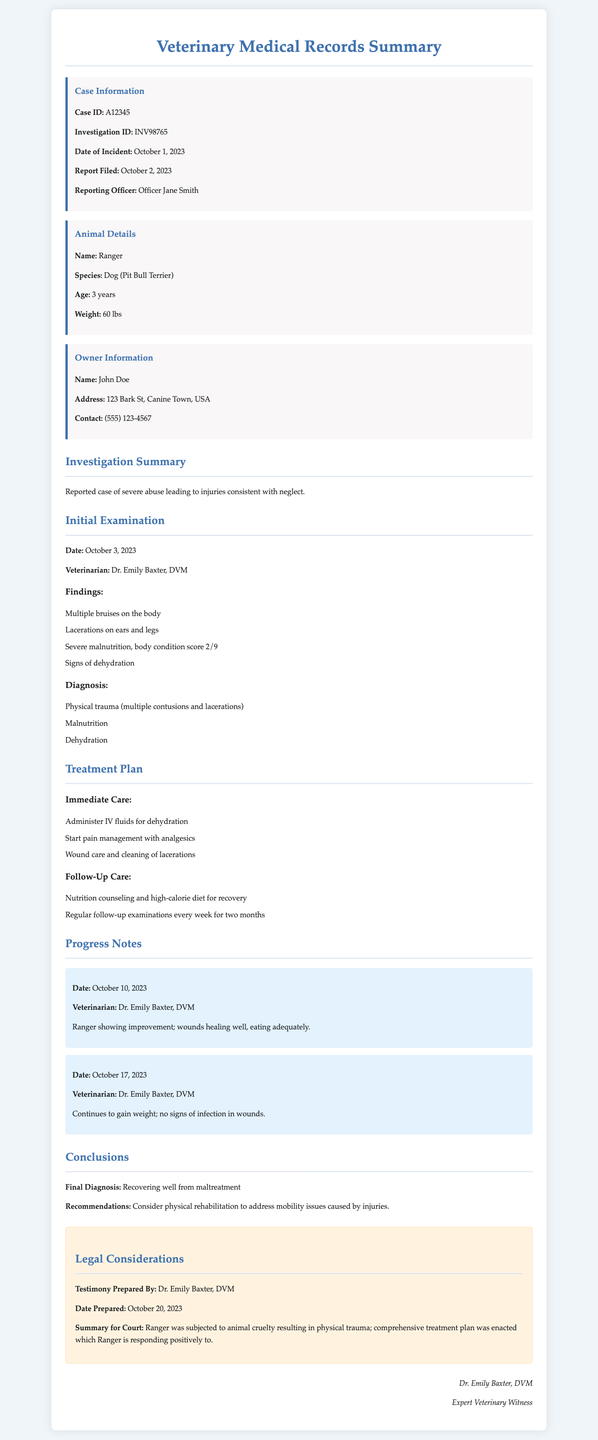What is the case ID? The case ID is mentioned in the case information section of the document.
Answer: A12345 Who is the reporting officer? The reporting officer's name is listed in the case information section.
Answer: Officer Jane Smith What species is the animal involved? The species of the animal, Ranger, is stated in the animal details section.
Answer: Dog (Pit Bull Terrier) What was the initial finding related to the dog's body condition? The initial examination section provides specific details about the dog's health condition.
Answer: Body condition score 2/9 What treatments were included in the immediate care plan? The treatment plan section outlines immediate care, which includes specific medical actions.
Answer: Administer IV fluids for dehydration How many weeks of follow-up examinations are planned? The follow-up care section specifies the duration of the follow-up examinations.
Answer: Two months What is the final diagnosis of the animal? The conclusion section clearly states the final diagnosis based on the treatment and recovery progress.
Answer: Recovering well from maltreatment What is recommended to address mobility issues? The conclusions section mentions recommendations for further care related to mobility.
Answer: Consider physical rehabilitation 